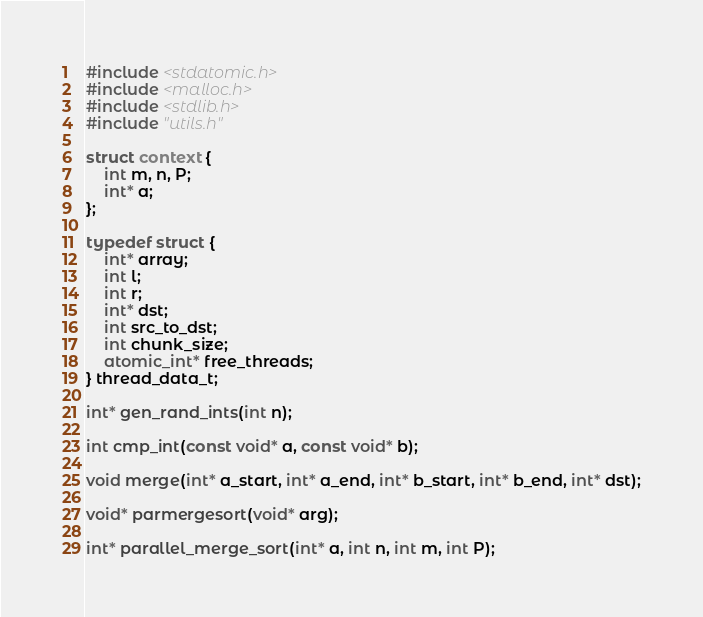Convert code to text. <code><loc_0><loc_0><loc_500><loc_500><_C_>#include <stdatomic.h>
#include <malloc.h>
#include <stdlib.h>
#include "utils.h"

struct context {
    int m, n, P;
    int* a;
};

typedef struct {
    int* array;
    int l;
    int r;
    int* dst;
    int src_to_dst;
    int chunk_size;
    atomic_int* free_threads;
} thread_data_t;

int* gen_rand_ints(int n);

int cmp_int(const void* a, const void* b);

void merge(int* a_start, int* a_end, int* b_start, int* b_end, int* dst);

void* parmergesort(void* arg);

int* parallel_merge_sort(int* a, int n, int m, int P);
</code> 